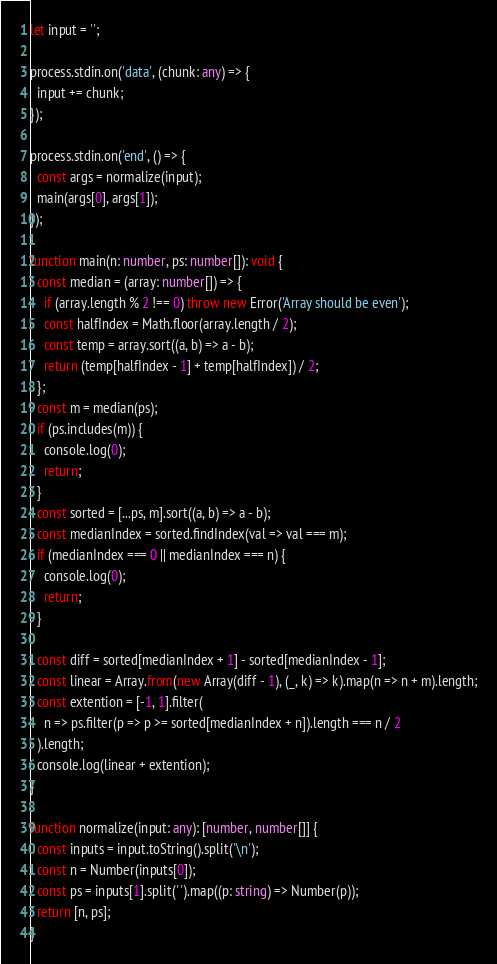<code> <loc_0><loc_0><loc_500><loc_500><_TypeScript_>let input = '';

process.stdin.on('data', (chunk: any) => {
  input += chunk;
});

process.stdin.on('end', () => {
  const args = normalize(input);
  main(args[0], args[1]);
});

function main(n: number, ps: number[]): void {
  const median = (array: number[]) => {
    if (array.length % 2 !== 0) throw new Error('Array should be even');
    const halfIndex = Math.floor(array.length / 2);
    const temp = array.sort((a, b) => a - b);
    return (temp[halfIndex - 1] + temp[halfIndex]) / 2;
  };
  const m = median(ps);
  if (ps.includes(m)) {
    console.log(0);
    return;
  }
  const sorted = [...ps, m].sort((a, b) => a - b);
  const medianIndex = sorted.findIndex(val => val === m);
  if (medianIndex === 0 || medianIndex === n) {
    console.log(0);
    return;
  }

  const diff = sorted[medianIndex + 1] - sorted[medianIndex - 1];
  const linear = Array.from(new Array(diff - 1), (_, k) => k).map(n => n + m).length;
  const extention = [-1, 1].filter(
    n => ps.filter(p => p >= sorted[medianIndex + n]).length === n / 2
  ).length;
  console.log(linear + extention);
}

function normalize(input: any): [number, number[]] {
  const inputs = input.toString().split('\n');
  const n = Number(inputs[0]);
  const ps = inputs[1].split(' ').map((p: string) => Number(p));
  return [n, ps];
}
</code> 